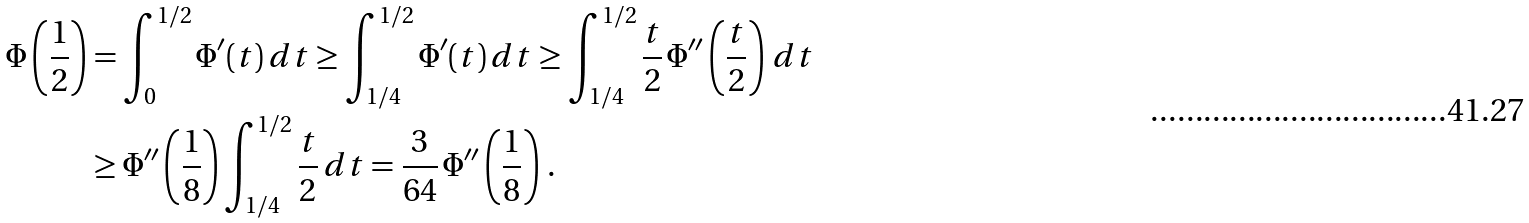<formula> <loc_0><loc_0><loc_500><loc_500>\Phi \left ( \frac { 1 } { 2 } \right ) & = \int _ { 0 } ^ { 1 / 2 } \Phi ^ { \prime } ( t ) \, d t \geq \int _ { 1 / 4 } ^ { 1 / 2 } \Phi ^ { \prime } ( t ) \, d t \geq \int _ { 1 / 4 } ^ { 1 / 2 } \frac { t } { 2 } \, \Phi ^ { \prime \prime } \left ( \frac { t } { 2 } \right ) \, d t \\ & \geq \Phi ^ { \prime \prime } \left ( \frac { 1 } { 8 } \right ) \int _ { 1 / 4 } ^ { 1 / 2 } \frac { t } { 2 } \, d t = \frac { 3 } { 6 4 } \, \Phi ^ { \prime \prime } \left ( \frac { 1 } { 8 } \right ) \, .</formula> 